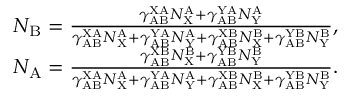Convert formula to latex. <formula><loc_0><loc_0><loc_500><loc_500>\begin{array} { r } { N _ { B } = \frac { \gamma _ { A B } ^ { X A } N _ { X } ^ { A } + \gamma _ { A B } ^ { Y A } N _ { Y } ^ { A } } { \gamma _ { A B } ^ { X A } N _ { X } ^ { A } + \gamma _ { A B } ^ { Y A } N _ { Y } ^ { A } + \gamma _ { A B } ^ { X B } N _ { X } ^ { B } + \gamma _ { A B } ^ { Y B } N _ { Y } ^ { B } } , } \\ { N _ { A } = \frac { \gamma _ { A B } ^ { X B } N _ { X } ^ { B } + \gamma _ { A B } ^ { Y B } N _ { Y } ^ { B } } { \gamma _ { A B } ^ { X A } N _ { X } ^ { A } + \gamma _ { A B } ^ { Y A } N _ { Y } ^ { A } + \gamma _ { A B } ^ { X B } N _ { X } ^ { B } + \gamma _ { A B } ^ { Y B } N _ { Y } ^ { B } } . } \end{array}</formula> 